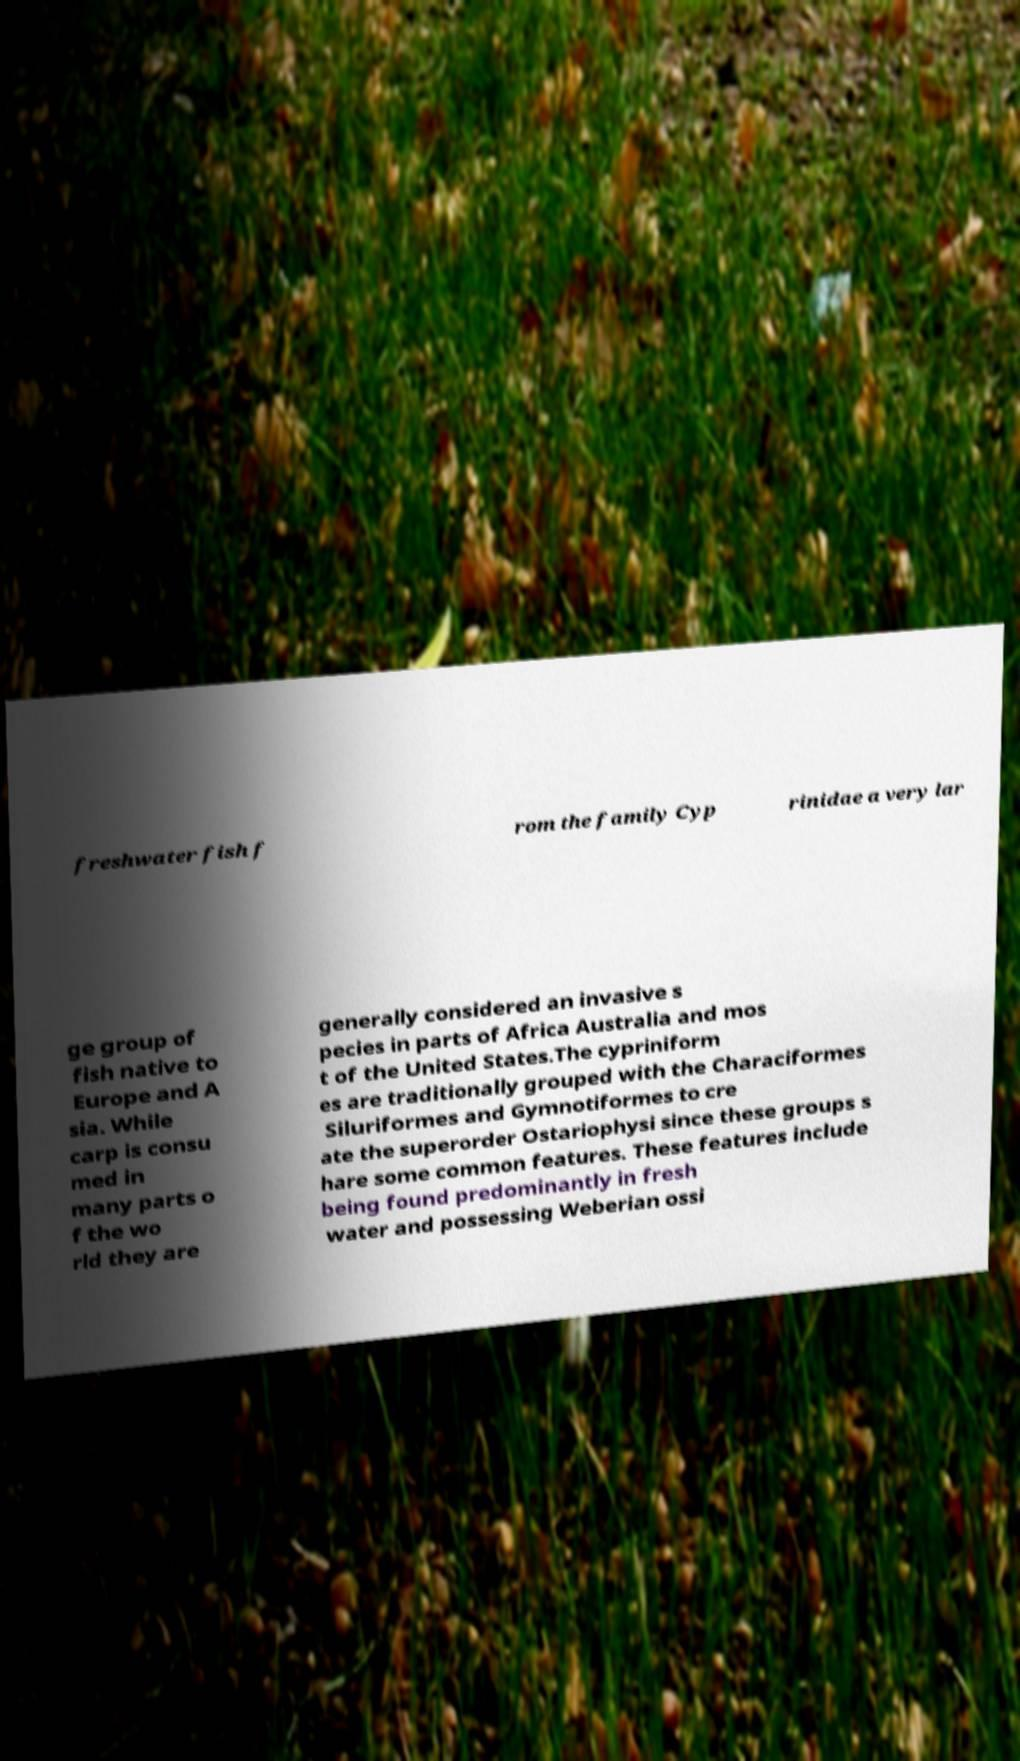Could you assist in decoding the text presented in this image and type it out clearly? freshwater fish f rom the family Cyp rinidae a very lar ge group of fish native to Europe and A sia. While carp is consu med in many parts o f the wo rld they are generally considered an invasive s pecies in parts of Africa Australia and mos t of the United States.The cypriniform es are traditionally grouped with the Characiformes Siluriformes and Gymnotiformes to cre ate the superorder Ostariophysi since these groups s hare some common features. These features include being found predominantly in fresh water and possessing Weberian ossi 